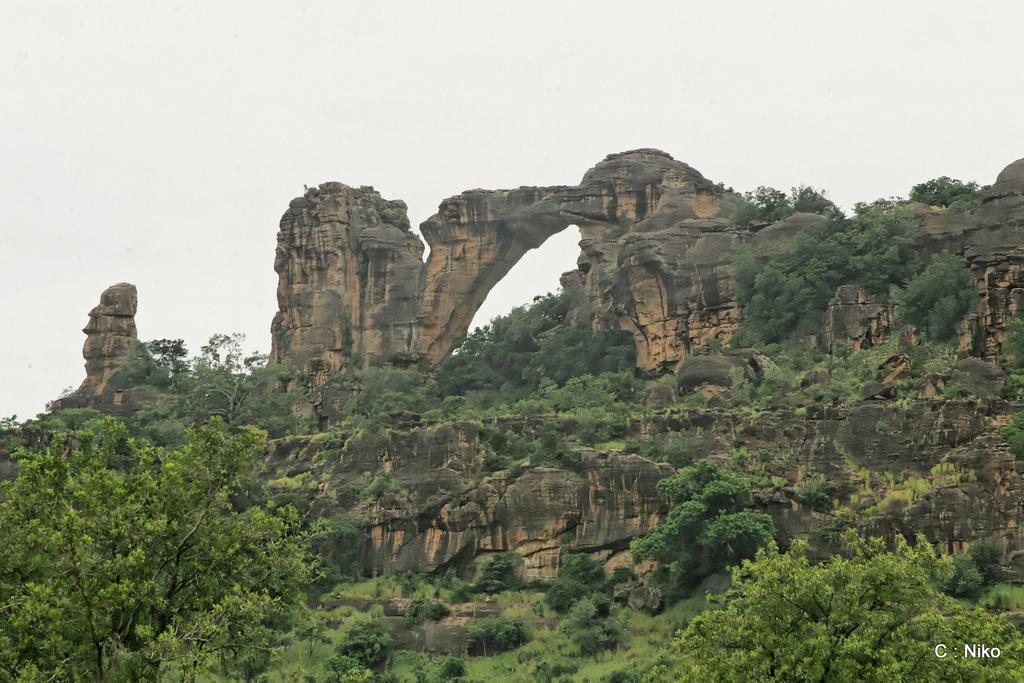What type of vegetation can be seen in the image? There are trees, plants, and grass in the image. What other natural elements are present in the image? There are rocks in the image. What is visible in the background of the image? The sky is visible in the image. Is there any text or symbol in the image? Yes, there is a watermark in the bottom right corner of the image. Can you describe the harmony between the trees and the rocks in the image? There is no mention of harmony between the trees and rocks in the image; the question is not based on the provided facts. 